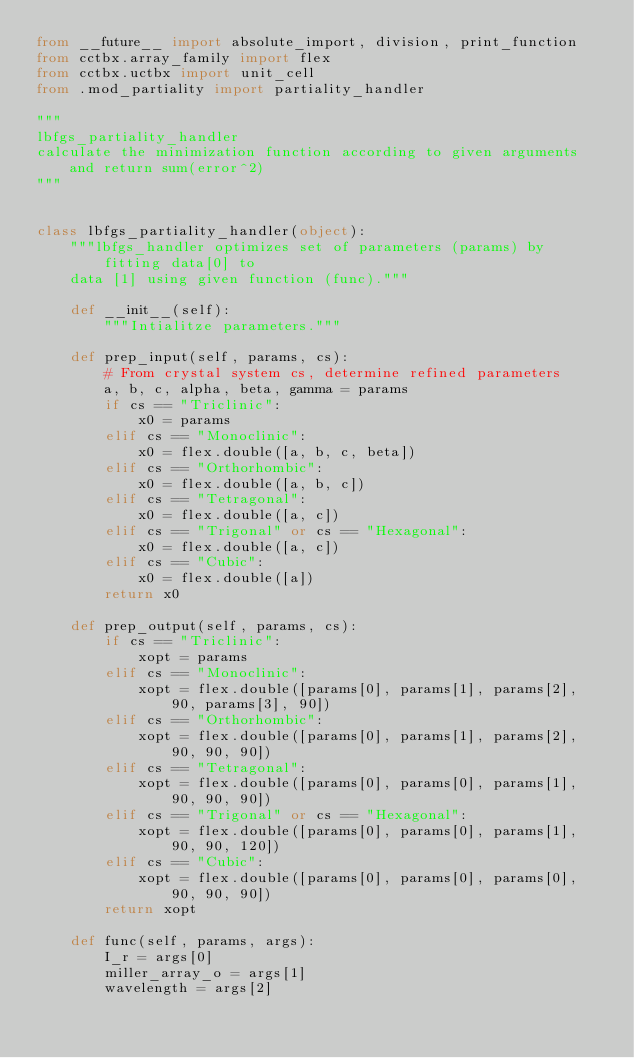Convert code to text. <code><loc_0><loc_0><loc_500><loc_500><_Python_>from __future__ import absolute_import, division, print_function
from cctbx.array_family import flex
from cctbx.uctbx import unit_cell
from .mod_partiality import partiality_handler

"""
lbfgs_partiality_handler
calculate the minimization function according to given arguments and return sum(error^2)
"""


class lbfgs_partiality_handler(object):
    """lbfgs_handler optimizes set of parameters (params) by fitting data[0] to
    data [1] using given function (func)."""

    def __init__(self):
        """Intialitze parameters."""

    def prep_input(self, params, cs):
        # From crystal system cs, determine refined parameters
        a, b, c, alpha, beta, gamma = params
        if cs == "Triclinic":
            x0 = params
        elif cs == "Monoclinic":
            x0 = flex.double([a, b, c, beta])
        elif cs == "Orthorhombic":
            x0 = flex.double([a, b, c])
        elif cs == "Tetragonal":
            x0 = flex.double([a, c])
        elif cs == "Trigonal" or cs == "Hexagonal":
            x0 = flex.double([a, c])
        elif cs == "Cubic":
            x0 = flex.double([a])
        return x0

    def prep_output(self, params, cs):
        if cs == "Triclinic":
            xopt = params
        elif cs == "Monoclinic":
            xopt = flex.double([params[0], params[1], params[2], 90, params[3], 90])
        elif cs == "Orthorhombic":
            xopt = flex.double([params[0], params[1], params[2], 90, 90, 90])
        elif cs == "Tetragonal":
            xopt = flex.double([params[0], params[0], params[1], 90, 90, 90])
        elif cs == "Trigonal" or cs == "Hexagonal":
            xopt = flex.double([params[0], params[0], params[1], 90, 90, 120])
        elif cs == "Cubic":
            xopt = flex.double([params[0], params[0], params[0], 90, 90, 90])
        return xopt

    def func(self, params, args):
        I_r = args[0]
        miller_array_o = args[1]
        wavelength = args[2]</code> 